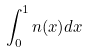<formula> <loc_0><loc_0><loc_500><loc_500>\int _ { 0 } ^ { 1 } n ( x ) d x</formula> 